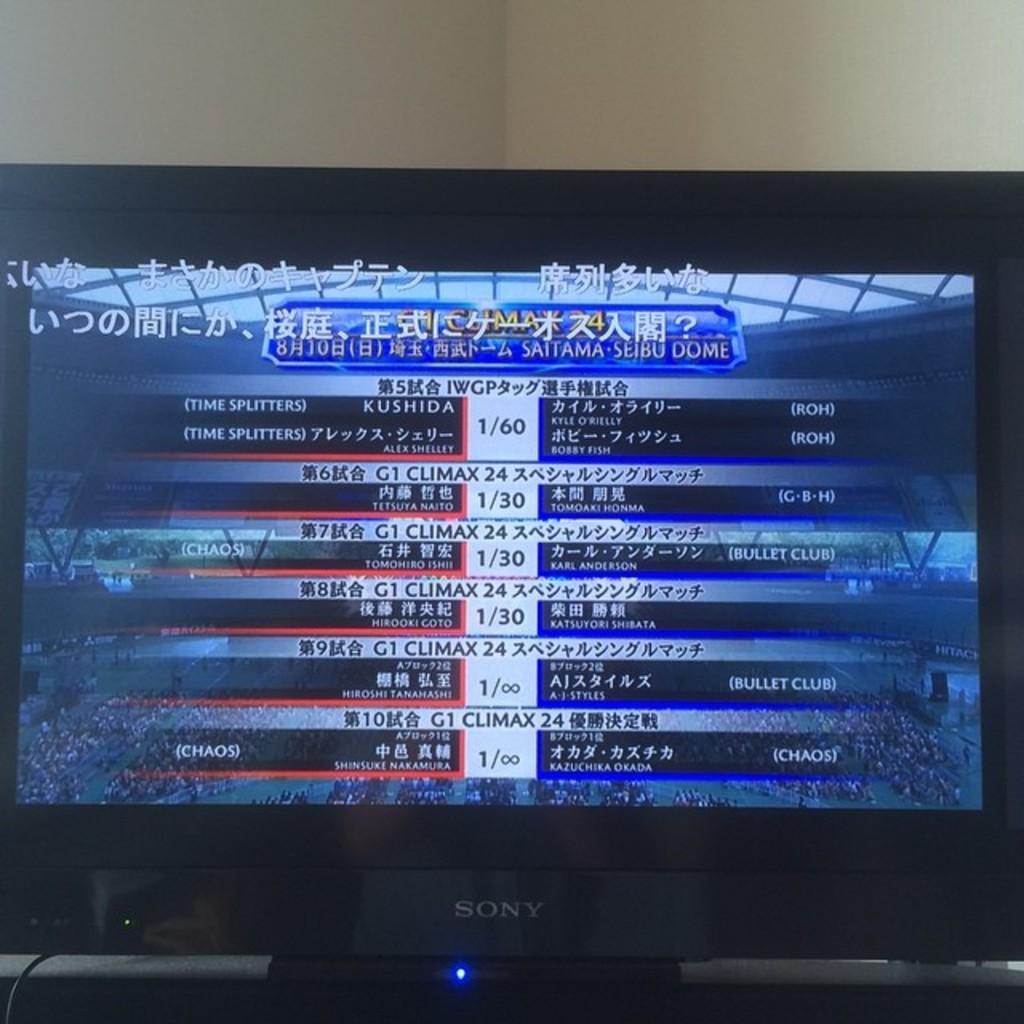What is the name of one of the english teams?
Give a very brief answer. Chaos. 